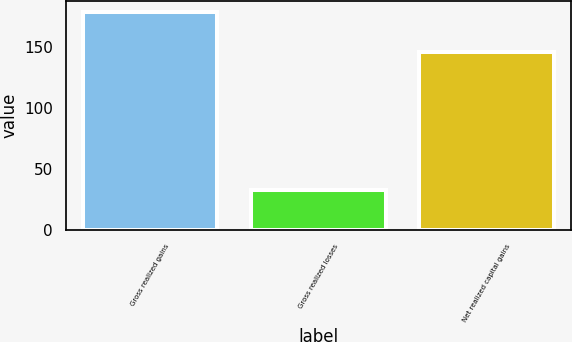Convert chart. <chart><loc_0><loc_0><loc_500><loc_500><bar_chart><fcel>Gross realized gains<fcel>Gross realized losses<fcel>Net realized capital gains<nl><fcel>179<fcel>33<fcel>146<nl></chart> 